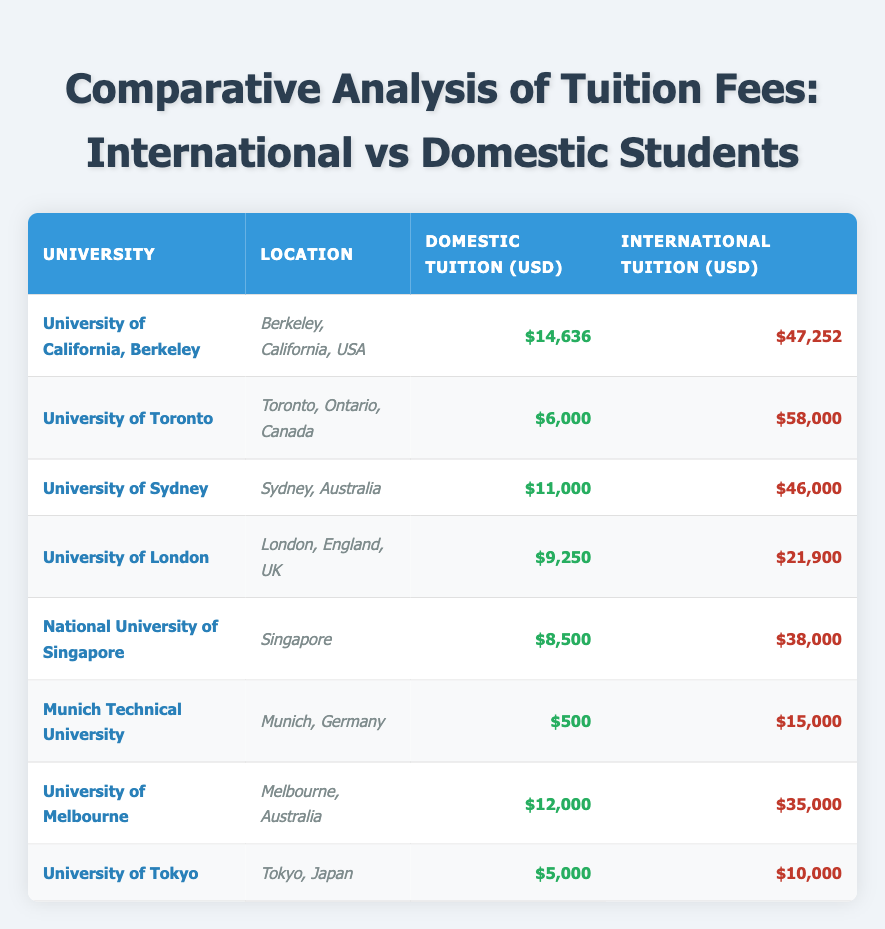What is the highest tuition fee for international students in the table? The highest tuition fee for international students is listed under the University of Toronto, which is 58,000 USD.
Answer: 58,000 USD Which university has the lowest domestic tuition fees? The university with the lowest domestic tuition fees is Munich Technical University, with a tuition fee of 500 USD.
Answer: 500 USD What is the average difference in tuition fees for international students compared to domestic students across all universities? To find the average difference, the individual differences are calculated: (47252 - 14636), (58000 - 6000), (46000 - 11000), (21900 - 9250), (38000 - 8500), (15000 - 500), (35000 - 12000), (10000 - 5000). The total difference is 32616 + 52000 + 35000 + 12650 + 29500 + 14500 + 23000 + 5000 = 103816. Dividing by 8 gives an average difference of 12977 USD.
Answer: 12977 USD Is it true that all universities have higher tuition fees for international students compared to domestic students? Yes, every university listed shows a higher fee for international students than for domestic students. Each corresponding row in the table confirms this.
Answer: Yes What is the total domestic tuition fee for all universities combined? The total domestic tuition fees are calculated by summing up all the domestic fees: 14636 + 6000 + 11000 + 9250 + 8500 + 500 + 12000 + 5000 = 51086 USD.
Answer: 51086 USD Which location has the highest tuition fees for domestic students? The location with the highest domestic tuition fees is the University of California, Berkeley at 14,636 USD.
Answer: 14,636 USD What percentage of the tuition fee at the University of Sydney is for international students? The tuition fee for international students at the University of Sydney is 46,000 USD, and domestic fees are 11,000 USD. The percentage is calculated as (46000 / (46000 + 11000)) * 100 = 80.65%, which indicates that approximately 80.65% of the total fee is for international students.
Answer: 80.65% Among the universities listed, does the University of Tokyo have both the lowest domestic and international tuition fees? No, while the University of Tokyo has the lowest domestic fee (5,000 USD), it does not have the lowest international fee, which is lower for universities like Munich Technical University (15,000 USD).
Answer: No 